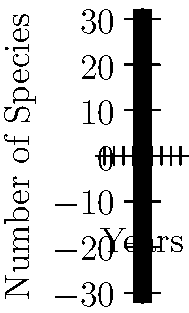Based on the graph comparing species diversity over time in areas with and without community gardens, what is the approximate percentage increase in the number of species after 5 years in areas with community gardens compared to areas without them? To solve this question, we need to follow these steps:

1. Identify the number of species at the 5-year mark for both scenarios:
   - With community gardens: 40 species
   - Without community gardens: 20 species

2. Calculate the difference in species count:
   $40 - 20 = 20$ species

3. Calculate the percentage increase:
   Percentage increase = $\frac{\text{Increase}}{\text{Original Value}} \times 100\%$
   
   $\frac{20}{20} \times 100\% = 100\%$

Therefore, after 5 years, areas with community gardens have approximately 100% more species compared to areas without community gardens.

This significant increase in biodiversity highlights the positive impact of community gardens on local ecosystems, which aligns with the eco-friendly initiatives that a Bayonne resident advocating for community development would be interested in.
Answer: 100% 